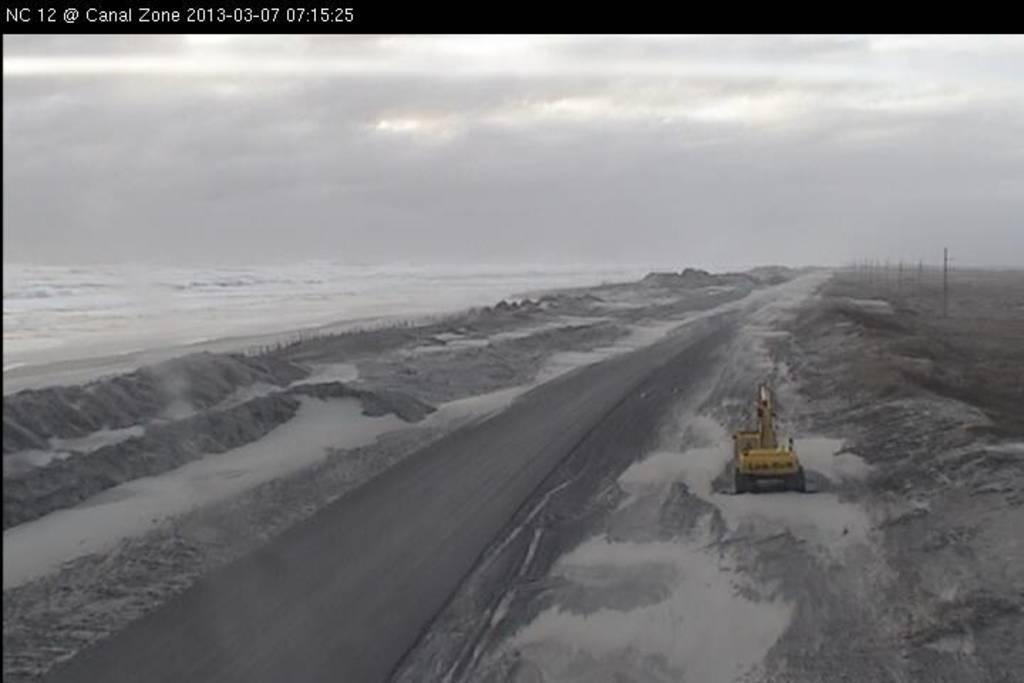Could you give a brief overview of what you see in this image? This is a black and white picture. I can see a vehicle, there is sand, there is water, and in the background there is the sky and there is a watermark on the image. 